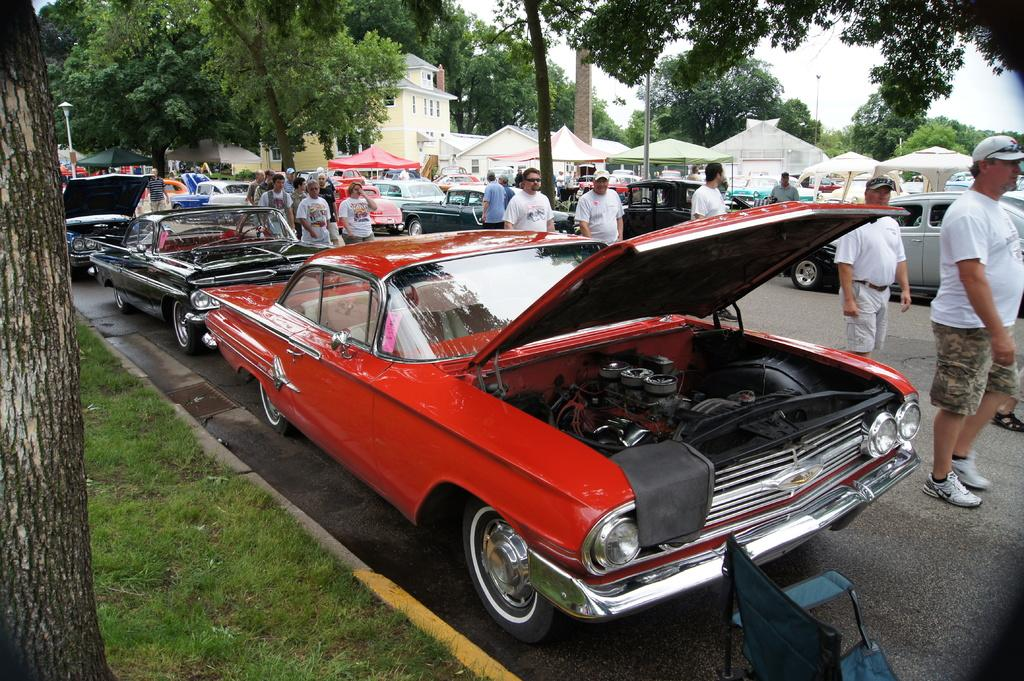What is the main feature of the image? There is a road in the image. What is happening on the road? Vehicles are parked on the road, and people are walking on it. What can be seen in the background of the image? There are trees and tents in the background of the image. What type of toys can be seen being used for writing in the image? There are no toys or writing activities present in the image. 